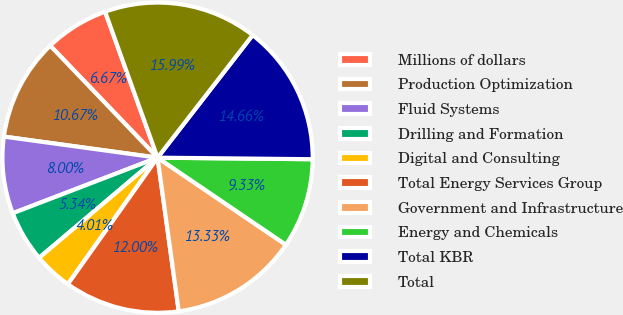Convert chart. <chart><loc_0><loc_0><loc_500><loc_500><pie_chart><fcel>Millions of dollars<fcel>Production Optimization<fcel>Fluid Systems<fcel>Drilling and Formation<fcel>Digital and Consulting<fcel>Total Energy Services Group<fcel>Government and Infrastructure<fcel>Energy and Chemicals<fcel>Total KBR<fcel>Total<nl><fcel>6.67%<fcel>10.67%<fcel>8.0%<fcel>5.34%<fcel>4.01%<fcel>12.0%<fcel>13.33%<fcel>9.33%<fcel>14.66%<fcel>15.99%<nl></chart> 